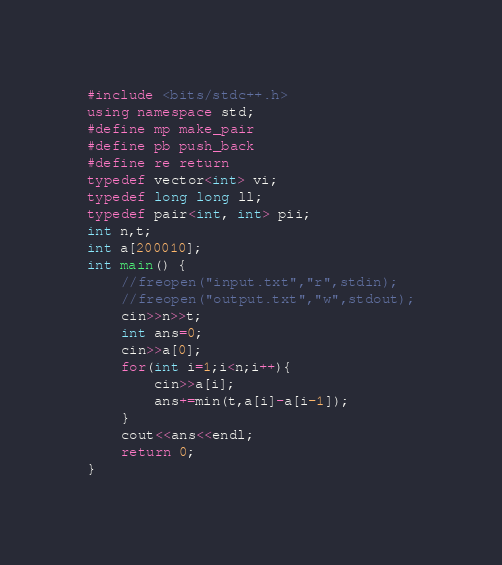<code> <loc_0><loc_0><loc_500><loc_500><_C++_>#include <bits/stdc++.h>
using namespace std;
#define mp make_pair
#define pb push_back
#define re return
typedef vector<int> vi;
typedef long long ll;
typedef pair<int, int> pii;
int n,t;
int a[200010];
int main() { 
    //freopen("input.txt","r",stdin);
	//freopen("output.txt","w",stdout);
	cin>>n>>t;
	int ans=0;
	cin>>a[0];
	for(int i=1;i<n;i++){
		cin>>a[i];
		ans+=min(t,a[i]-a[i-1]);
	}
	cout<<ans<<endl;
    return 0; 
}</code> 